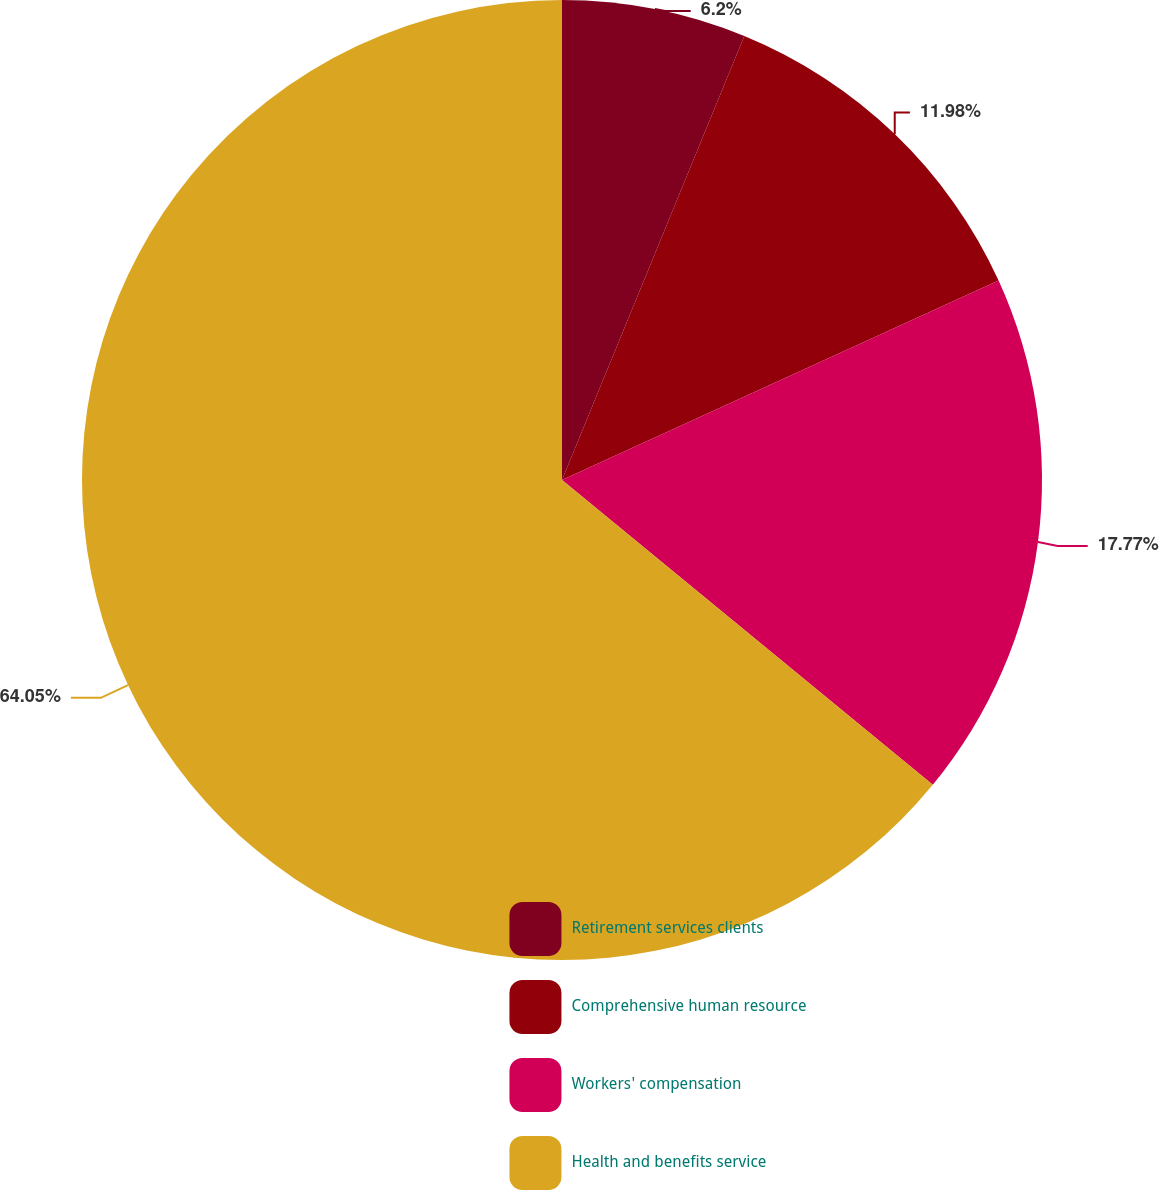<chart> <loc_0><loc_0><loc_500><loc_500><pie_chart><fcel>Retirement services clients<fcel>Comprehensive human resource<fcel>Workers' compensation<fcel>Health and benefits service<nl><fcel>6.2%<fcel>11.98%<fcel>17.77%<fcel>64.05%<nl></chart> 